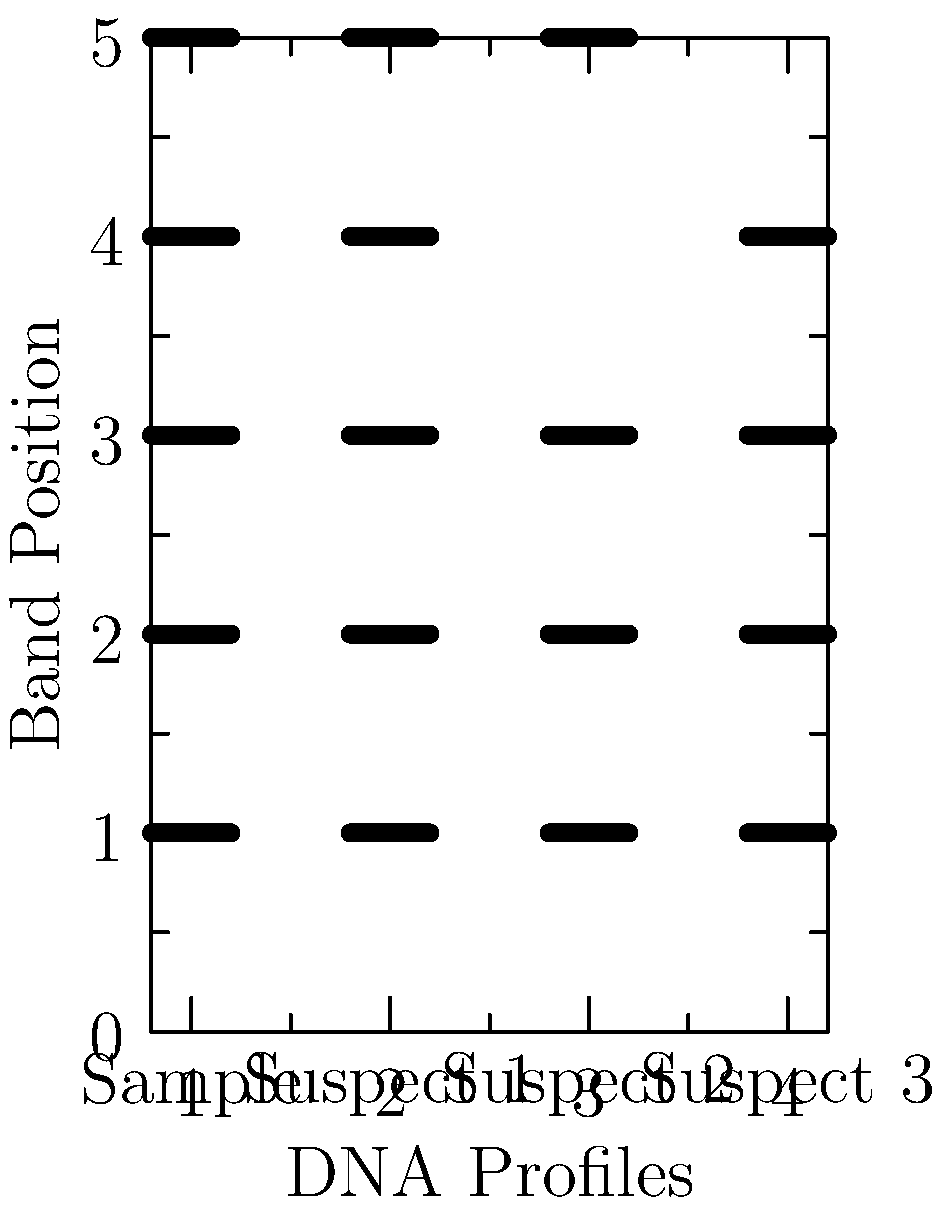In a DNA profiling analysis for a murder case, the forensic lab produced the electrophoresis results shown above. Based on these results, which suspect's DNA profile is the most likely match to the sample found at the crime scene? To determine the most likely match, we need to compare the DNA profiles of each suspect with the sample:

1. Examine the sample profile:
   The sample shows 5 distinct bands at positions 1, 2, 3, 4, and 5.

2. Compare Suspect 1's profile:
   Suspect 1 also shows 5 bands at positions 1, 2, 3, 4, and 5.
   This is an exact match to the sample.

3. Compare Suspect 2's profile:
   Suspect 2 shows 4 bands at positions 1, 2, 3, and 5.
   It's missing the band at position 4 compared to the sample.

4. Compare Suspect 3's profile:
   Suspect 3 shows 4 bands at positions 1, 2, 3, and 4.
   It's missing the band at position 5 compared to the sample.

5. Evaluate the results:
   Suspect 1 has an exact match with the sample, showing all 5 bands in the same positions.
   Suspects 2 and 3 both have partial matches, each missing one band.

Therefore, based on these electrophoresis results, Suspect 1's DNA profile is the most likely match to the sample found at the crime scene.
Answer: Suspect 1 